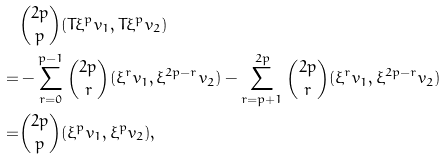<formula> <loc_0><loc_0><loc_500><loc_500>& \binom { 2 p } { p } ( T \xi ^ { p } v _ { 1 } , T \xi ^ { p } v _ { 2 } ) \\ = & - \sum _ { r = 0 } ^ { p - 1 } \binom { 2 p } { r } ( \xi ^ { r } v _ { 1 } , \xi ^ { 2 p - r } v _ { 2 } ) - \sum _ { r = p + 1 } ^ { 2 p } \binom { 2 p } { r } ( \xi ^ { r } v _ { 1 } , \xi ^ { 2 p - r } v _ { 2 } ) \\ = & \binom { 2 p } { p } ( \xi ^ { p } v _ { 1 } , \xi ^ { p } v _ { 2 } ) ,</formula> 